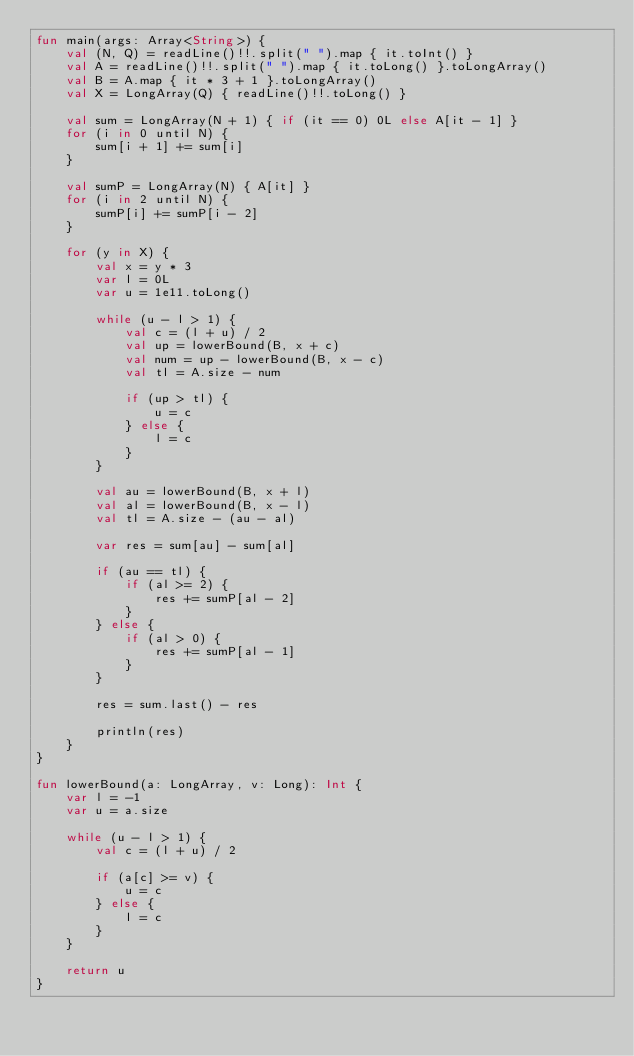<code> <loc_0><loc_0><loc_500><loc_500><_Kotlin_>fun main(args: Array<String>) {
    val (N, Q) = readLine()!!.split(" ").map { it.toInt() }
    val A = readLine()!!.split(" ").map { it.toLong() }.toLongArray()
    val B = A.map { it * 3 + 1 }.toLongArray()
    val X = LongArray(Q) { readLine()!!.toLong() }

    val sum = LongArray(N + 1) { if (it == 0) 0L else A[it - 1] }
    for (i in 0 until N) {
        sum[i + 1] += sum[i]
    }

    val sumP = LongArray(N) { A[it] }
    for (i in 2 until N) {
        sumP[i] += sumP[i - 2]
    }

    for (y in X) {
        val x = y * 3
        var l = 0L
        var u = 1e11.toLong()

        while (u - l > 1) {
            val c = (l + u) / 2
            val up = lowerBound(B, x + c)
            val num = up - lowerBound(B, x - c)
            val tl = A.size - num

            if (up > tl) {
                u = c
            } else {
                l = c
            }
        }

        val au = lowerBound(B, x + l)
        val al = lowerBound(B, x - l)
        val tl = A.size - (au - al)

        var res = sum[au] - sum[al]

        if (au == tl) {
            if (al >= 2) {
                res += sumP[al - 2]
            }
        } else {
            if (al > 0) {
                res += sumP[al - 1]
            }
        }

        res = sum.last() - res

        println(res)
    }
}

fun lowerBound(a: LongArray, v: Long): Int {
    var l = -1
    var u = a.size

    while (u - l > 1) {
        val c = (l + u) / 2

        if (a[c] >= v) {
            u = c
        } else {
            l = c
        }
    }

    return u
}
</code> 